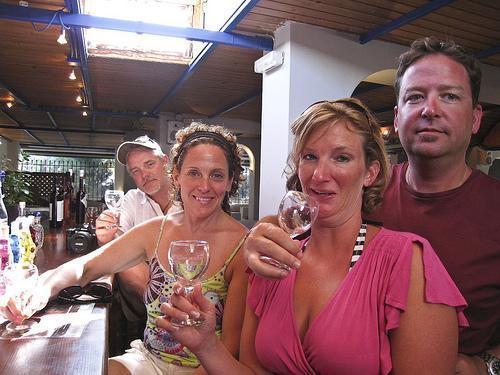How many people are in the picture?
Give a very brief answer. 4. 